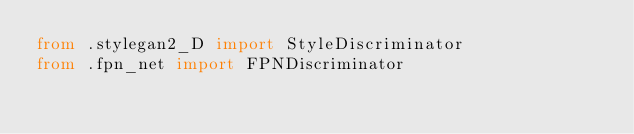<code> <loc_0><loc_0><loc_500><loc_500><_Python_>from .stylegan2_D import StyleDiscriminator
from .fpn_net import FPNDiscriminator</code> 